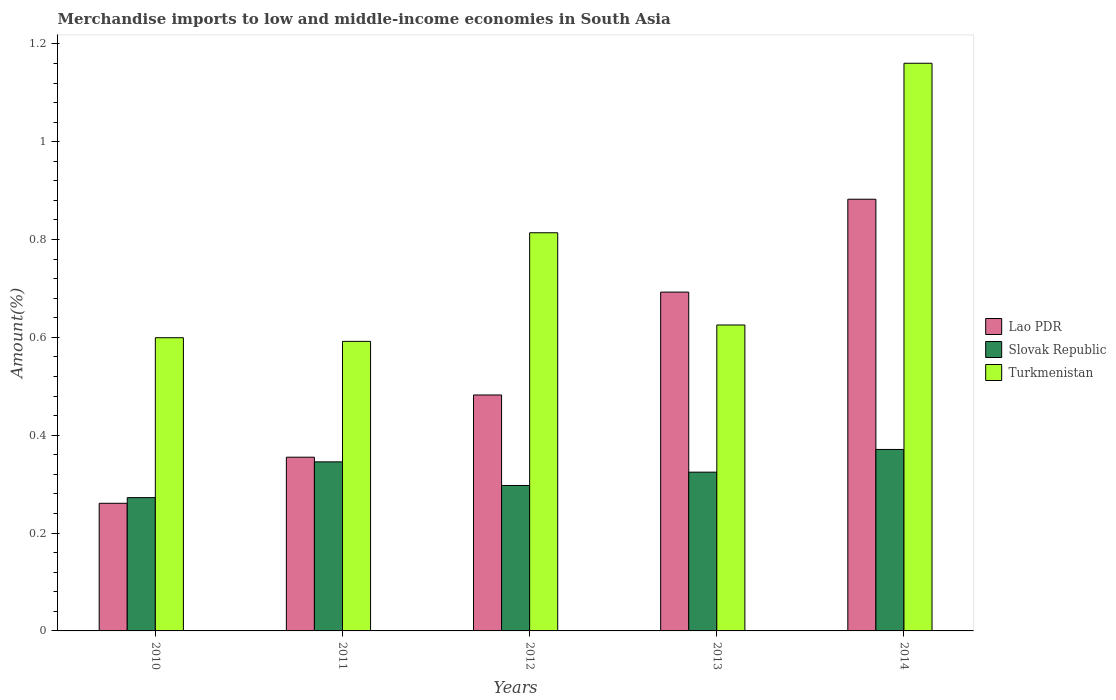How many groups of bars are there?
Your answer should be compact. 5. Are the number of bars per tick equal to the number of legend labels?
Your answer should be very brief. Yes. How many bars are there on the 4th tick from the left?
Keep it short and to the point. 3. How many bars are there on the 4th tick from the right?
Give a very brief answer. 3. What is the label of the 5th group of bars from the left?
Your answer should be compact. 2014. What is the percentage of amount earned from merchandise imports in Lao PDR in 2013?
Your answer should be compact. 0.69. Across all years, what is the maximum percentage of amount earned from merchandise imports in Turkmenistan?
Offer a terse response. 1.16. Across all years, what is the minimum percentage of amount earned from merchandise imports in Slovak Republic?
Offer a very short reply. 0.27. In which year was the percentage of amount earned from merchandise imports in Lao PDR maximum?
Offer a very short reply. 2014. What is the total percentage of amount earned from merchandise imports in Turkmenistan in the graph?
Offer a terse response. 3.79. What is the difference between the percentage of amount earned from merchandise imports in Turkmenistan in 2010 and that in 2014?
Provide a succinct answer. -0.56. What is the difference between the percentage of amount earned from merchandise imports in Lao PDR in 2011 and the percentage of amount earned from merchandise imports in Slovak Republic in 2010?
Your answer should be very brief. 0.08. What is the average percentage of amount earned from merchandise imports in Slovak Republic per year?
Give a very brief answer. 0.32. In the year 2013, what is the difference between the percentage of amount earned from merchandise imports in Turkmenistan and percentage of amount earned from merchandise imports in Slovak Republic?
Your answer should be very brief. 0.3. In how many years, is the percentage of amount earned from merchandise imports in Lao PDR greater than 0.68 %?
Provide a succinct answer. 2. What is the ratio of the percentage of amount earned from merchandise imports in Slovak Republic in 2011 to that in 2014?
Provide a short and direct response. 0.93. Is the difference between the percentage of amount earned from merchandise imports in Turkmenistan in 2010 and 2014 greater than the difference between the percentage of amount earned from merchandise imports in Slovak Republic in 2010 and 2014?
Offer a terse response. No. What is the difference between the highest and the second highest percentage of amount earned from merchandise imports in Turkmenistan?
Give a very brief answer. 0.35. What is the difference between the highest and the lowest percentage of amount earned from merchandise imports in Slovak Republic?
Keep it short and to the point. 0.1. What does the 1st bar from the left in 2012 represents?
Offer a very short reply. Lao PDR. What does the 2nd bar from the right in 2012 represents?
Give a very brief answer. Slovak Republic. What is the difference between two consecutive major ticks on the Y-axis?
Offer a terse response. 0.2. Does the graph contain any zero values?
Your answer should be very brief. No. Does the graph contain grids?
Your answer should be very brief. No. How many legend labels are there?
Your response must be concise. 3. What is the title of the graph?
Your response must be concise. Merchandise imports to low and middle-income economies in South Asia. What is the label or title of the X-axis?
Make the answer very short. Years. What is the label or title of the Y-axis?
Offer a very short reply. Amount(%). What is the Amount(%) of Lao PDR in 2010?
Give a very brief answer. 0.26. What is the Amount(%) of Slovak Republic in 2010?
Provide a succinct answer. 0.27. What is the Amount(%) in Turkmenistan in 2010?
Offer a very short reply. 0.6. What is the Amount(%) of Lao PDR in 2011?
Offer a terse response. 0.36. What is the Amount(%) in Slovak Republic in 2011?
Provide a succinct answer. 0.35. What is the Amount(%) in Turkmenistan in 2011?
Your response must be concise. 0.59. What is the Amount(%) of Lao PDR in 2012?
Keep it short and to the point. 0.48. What is the Amount(%) in Slovak Republic in 2012?
Your answer should be compact. 0.3. What is the Amount(%) of Turkmenistan in 2012?
Keep it short and to the point. 0.81. What is the Amount(%) in Lao PDR in 2013?
Provide a succinct answer. 0.69. What is the Amount(%) in Slovak Republic in 2013?
Your answer should be compact. 0.32. What is the Amount(%) in Turkmenistan in 2013?
Give a very brief answer. 0.63. What is the Amount(%) in Lao PDR in 2014?
Give a very brief answer. 0.88. What is the Amount(%) in Slovak Republic in 2014?
Ensure brevity in your answer.  0.37. What is the Amount(%) in Turkmenistan in 2014?
Your response must be concise. 1.16. Across all years, what is the maximum Amount(%) of Lao PDR?
Provide a succinct answer. 0.88. Across all years, what is the maximum Amount(%) of Slovak Republic?
Provide a short and direct response. 0.37. Across all years, what is the maximum Amount(%) of Turkmenistan?
Your answer should be very brief. 1.16. Across all years, what is the minimum Amount(%) in Lao PDR?
Make the answer very short. 0.26. Across all years, what is the minimum Amount(%) in Slovak Republic?
Provide a succinct answer. 0.27. Across all years, what is the minimum Amount(%) of Turkmenistan?
Provide a succinct answer. 0.59. What is the total Amount(%) in Lao PDR in the graph?
Keep it short and to the point. 2.67. What is the total Amount(%) of Slovak Republic in the graph?
Your answer should be compact. 1.61. What is the total Amount(%) in Turkmenistan in the graph?
Give a very brief answer. 3.79. What is the difference between the Amount(%) of Lao PDR in 2010 and that in 2011?
Ensure brevity in your answer.  -0.09. What is the difference between the Amount(%) of Slovak Republic in 2010 and that in 2011?
Your response must be concise. -0.07. What is the difference between the Amount(%) of Turkmenistan in 2010 and that in 2011?
Make the answer very short. 0.01. What is the difference between the Amount(%) of Lao PDR in 2010 and that in 2012?
Provide a succinct answer. -0.22. What is the difference between the Amount(%) of Slovak Republic in 2010 and that in 2012?
Keep it short and to the point. -0.02. What is the difference between the Amount(%) in Turkmenistan in 2010 and that in 2012?
Make the answer very short. -0.21. What is the difference between the Amount(%) of Lao PDR in 2010 and that in 2013?
Make the answer very short. -0.43. What is the difference between the Amount(%) of Slovak Republic in 2010 and that in 2013?
Make the answer very short. -0.05. What is the difference between the Amount(%) of Turkmenistan in 2010 and that in 2013?
Make the answer very short. -0.03. What is the difference between the Amount(%) of Lao PDR in 2010 and that in 2014?
Your answer should be very brief. -0.62. What is the difference between the Amount(%) of Slovak Republic in 2010 and that in 2014?
Ensure brevity in your answer.  -0.1. What is the difference between the Amount(%) of Turkmenistan in 2010 and that in 2014?
Ensure brevity in your answer.  -0.56. What is the difference between the Amount(%) in Lao PDR in 2011 and that in 2012?
Your answer should be very brief. -0.13. What is the difference between the Amount(%) of Slovak Republic in 2011 and that in 2012?
Provide a short and direct response. 0.05. What is the difference between the Amount(%) of Turkmenistan in 2011 and that in 2012?
Make the answer very short. -0.22. What is the difference between the Amount(%) in Lao PDR in 2011 and that in 2013?
Offer a terse response. -0.34. What is the difference between the Amount(%) in Slovak Republic in 2011 and that in 2013?
Ensure brevity in your answer.  0.02. What is the difference between the Amount(%) in Turkmenistan in 2011 and that in 2013?
Your response must be concise. -0.03. What is the difference between the Amount(%) of Lao PDR in 2011 and that in 2014?
Offer a very short reply. -0.53. What is the difference between the Amount(%) in Slovak Republic in 2011 and that in 2014?
Ensure brevity in your answer.  -0.03. What is the difference between the Amount(%) of Turkmenistan in 2011 and that in 2014?
Your response must be concise. -0.57. What is the difference between the Amount(%) of Lao PDR in 2012 and that in 2013?
Your answer should be very brief. -0.21. What is the difference between the Amount(%) in Slovak Republic in 2012 and that in 2013?
Ensure brevity in your answer.  -0.03. What is the difference between the Amount(%) of Turkmenistan in 2012 and that in 2013?
Offer a very short reply. 0.19. What is the difference between the Amount(%) of Lao PDR in 2012 and that in 2014?
Your answer should be compact. -0.4. What is the difference between the Amount(%) of Slovak Republic in 2012 and that in 2014?
Offer a terse response. -0.07. What is the difference between the Amount(%) in Turkmenistan in 2012 and that in 2014?
Give a very brief answer. -0.35. What is the difference between the Amount(%) in Lao PDR in 2013 and that in 2014?
Offer a terse response. -0.19. What is the difference between the Amount(%) of Slovak Republic in 2013 and that in 2014?
Ensure brevity in your answer.  -0.05. What is the difference between the Amount(%) of Turkmenistan in 2013 and that in 2014?
Give a very brief answer. -0.54. What is the difference between the Amount(%) in Lao PDR in 2010 and the Amount(%) in Slovak Republic in 2011?
Your answer should be compact. -0.08. What is the difference between the Amount(%) in Lao PDR in 2010 and the Amount(%) in Turkmenistan in 2011?
Offer a very short reply. -0.33. What is the difference between the Amount(%) of Slovak Republic in 2010 and the Amount(%) of Turkmenistan in 2011?
Your answer should be very brief. -0.32. What is the difference between the Amount(%) of Lao PDR in 2010 and the Amount(%) of Slovak Republic in 2012?
Give a very brief answer. -0.04. What is the difference between the Amount(%) in Lao PDR in 2010 and the Amount(%) in Turkmenistan in 2012?
Give a very brief answer. -0.55. What is the difference between the Amount(%) of Slovak Republic in 2010 and the Amount(%) of Turkmenistan in 2012?
Make the answer very short. -0.54. What is the difference between the Amount(%) in Lao PDR in 2010 and the Amount(%) in Slovak Republic in 2013?
Ensure brevity in your answer.  -0.06. What is the difference between the Amount(%) in Lao PDR in 2010 and the Amount(%) in Turkmenistan in 2013?
Your answer should be compact. -0.36. What is the difference between the Amount(%) of Slovak Republic in 2010 and the Amount(%) of Turkmenistan in 2013?
Offer a very short reply. -0.35. What is the difference between the Amount(%) in Lao PDR in 2010 and the Amount(%) in Slovak Republic in 2014?
Provide a succinct answer. -0.11. What is the difference between the Amount(%) of Lao PDR in 2010 and the Amount(%) of Turkmenistan in 2014?
Offer a terse response. -0.9. What is the difference between the Amount(%) of Slovak Republic in 2010 and the Amount(%) of Turkmenistan in 2014?
Keep it short and to the point. -0.89. What is the difference between the Amount(%) in Lao PDR in 2011 and the Amount(%) in Slovak Republic in 2012?
Offer a terse response. 0.06. What is the difference between the Amount(%) of Lao PDR in 2011 and the Amount(%) of Turkmenistan in 2012?
Give a very brief answer. -0.46. What is the difference between the Amount(%) in Slovak Republic in 2011 and the Amount(%) in Turkmenistan in 2012?
Make the answer very short. -0.47. What is the difference between the Amount(%) of Lao PDR in 2011 and the Amount(%) of Slovak Republic in 2013?
Keep it short and to the point. 0.03. What is the difference between the Amount(%) of Lao PDR in 2011 and the Amount(%) of Turkmenistan in 2013?
Give a very brief answer. -0.27. What is the difference between the Amount(%) in Slovak Republic in 2011 and the Amount(%) in Turkmenistan in 2013?
Offer a very short reply. -0.28. What is the difference between the Amount(%) of Lao PDR in 2011 and the Amount(%) of Slovak Republic in 2014?
Provide a succinct answer. -0.02. What is the difference between the Amount(%) in Lao PDR in 2011 and the Amount(%) in Turkmenistan in 2014?
Make the answer very short. -0.81. What is the difference between the Amount(%) in Slovak Republic in 2011 and the Amount(%) in Turkmenistan in 2014?
Offer a terse response. -0.81. What is the difference between the Amount(%) of Lao PDR in 2012 and the Amount(%) of Slovak Republic in 2013?
Offer a terse response. 0.16. What is the difference between the Amount(%) of Lao PDR in 2012 and the Amount(%) of Turkmenistan in 2013?
Keep it short and to the point. -0.14. What is the difference between the Amount(%) in Slovak Republic in 2012 and the Amount(%) in Turkmenistan in 2013?
Keep it short and to the point. -0.33. What is the difference between the Amount(%) of Lao PDR in 2012 and the Amount(%) of Slovak Republic in 2014?
Your answer should be compact. 0.11. What is the difference between the Amount(%) of Lao PDR in 2012 and the Amount(%) of Turkmenistan in 2014?
Your answer should be compact. -0.68. What is the difference between the Amount(%) of Slovak Republic in 2012 and the Amount(%) of Turkmenistan in 2014?
Your answer should be very brief. -0.86. What is the difference between the Amount(%) of Lao PDR in 2013 and the Amount(%) of Slovak Republic in 2014?
Provide a short and direct response. 0.32. What is the difference between the Amount(%) in Lao PDR in 2013 and the Amount(%) in Turkmenistan in 2014?
Offer a terse response. -0.47. What is the difference between the Amount(%) in Slovak Republic in 2013 and the Amount(%) in Turkmenistan in 2014?
Provide a succinct answer. -0.84. What is the average Amount(%) of Lao PDR per year?
Your answer should be compact. 0.53. What is the average Amount(%) in Slovak Republic per year?
Offer a very short reply. 0.32. What is the average Amount(%) in Turkmenistan per year?
Make the answer very short. 0.76. In the year 2010, what is the difference between the Amount(%) of Lao PDR and Amount(%) of Slovak Republic?
Offer a terse response. -0.01. In the year 2010, what is the difference between the Amount(%) of Lao PDR and Amount(%) of Turkmenistan?
Your response must be concise. -0.34. In the year 2010, what is the difference between the Amount(%) of Slovak Republic and Amount(%) of Turkmenistan?
Offer a terse response. -0.33. In the year 2011, what is the difference between the Amount(%) of Lao PDR and Amount(%) of Slovak Republic?
Provide a short and direct response. 0.01. In the year 2011, what is the difference between the Amount(%) of Lao PDR and Amount(%) of Turkmenistan?
Your response must be concise. -0.24. In the year 2011, what is the difference between the Amount(%) in Slovak Republic and Amount(%) in Turkmenistan?
Your answer should be compact. -0.25. In the year 2012, what is the difference between the Amount(%) in Lao PDR and Amount(%) in Slovak Republic?
Your answer should be compact. 0.18. In the year 2012, what is the difference between the Amount(%) in Lao PDR and Amount(%) in Turkmenistan?
Your answer should be very brief. -0.33. In the year 2012, what is the difference between the Amount(%) in Slovak Republic and Amount(%) in Turkmenistan?
Provide a succinct answer. -0.52. In the year 2013, what is the difference between the Amount(%) in Lao PDR and Amount(%) in Slovak Republic?
Keep it short and to the point. 0.37. In the year 2013, what is the difference between the Amount(%) in Lao PDR and Amount(%) in Turkmenistan?
Offer a terse response. 0.07. In the year 2013, what is the difference between the Amount(%) of Slovak Republic and Amount(%) of Turkmenistan?
Provide a succinct answer. -0.3. In the year 2014, what is the difference between the Amount(%) of Lao PDR and Amount(%) of Slovak Republic?
Your response must be concise. 0.51. In the year 2014, what is the difference between the Amount(%) of Lao PDR and Amount(%) of Turkmenistan?
Offer a very short reply. -0.28. In the year 2014, what is the difference between the Amount(%) in Slovak Republic and Amount(%) in Turkmenistan?
Provide a short and direct response. -0.79. What is the ratio of the Amount(%) in Lao PDR in 2010 to that in 2011?
Your response must be concise. 0.73. What is the ratio of the Amount(%) of Slovak Republic in 2010 to that in 2011?
Provide a succinct answer. 0.79. What is the ratio of the Amount(%) in Turkmenistan in 2010 to that in 2011?
Ensure brevity in your answer.  1.01. What is the ratio of the Amount(%) of Lao PDR in 2010 to that in 2012?
Ensure brevity in your answer.  0.54. What is the ratio of the Amount(%) in Slovak Republic in 2010 to that in 2012?
Provide a short and direct response. 0.92. What is the ratio of the Amount(%) in Turkmenistan in 2010 to that in 2012?
Ensure brevity in your answer.  0.74. What is the ratio of the Amount(%) of Lao PDR in 2010 to that in 2013?
Provide a short and direct response. 0.38. What is the ratio of the Amount(%) of Slovak Republic in 2010 to that in 2013?
Your response must be concise. 0.84. What is the ratio of the Amount(%) of Turkmenistan in 2010 to that in 2013?
Your answer should be compact. 0.96. What is the ratio of the Amount(%) of Lao PDR in 2010 to that in 2014?
Your answer should be compact. 0.3. What is the ratio of the Amount(%) of Slovak Republic in 2010 to that in 2014?
Make the answer very short. 0.73. What is the ratio of the Amount(%) of Turkmenistan in 2010 to that in 2014?
Keep it short and to the point. 0.52. What is the ratio of the Amount(%) in Lao PDR in 2011 to that in 2012?
Make the answer very short. 0.74. What is the ratio of the Amount(%) of Slovak Republic in 2011 to that in 2012?
Your answer should be compact. 1.16. What is the ratio of the Amount(%) of Turkmenistan in 2011 to that in 2012?
Your response must be concise. 0.73. What is the ratio of the Amount(%) of Lao PDR in 2011 to that in 2013?
Provide a succinct answer. 0.51. What is the ratio of the Amount(%) of Slovak Republic in 2011 to that in 2013?
Provide a short and direct response. 1.06. What is the ratio of the Amount(%) in Turkmenistan in 2011 to that in 2013?
Keep it short and to the point. 0.95. What is the ratio of the Amount(%) in Lao PDR in 2011 to that in 2014?
Keep it short and to the point. 0.4. What is the ratio of the Amount(%) of Slovak Republic in 2011 to that in 2014?
Give a very brief answer. 0.93. What is the ratio of the Amount(%) in Turkmenistan in 2011 to that in 2014?
Your answer should be compact. 0.51. What is the ratio of the Amount(%) in Lao PDR in 2012 to that in 2013?
Give a very brief answer. 0.7. What is the ratio of the Amount(%) in Slovak Republic in 2012 to that in 2013?
Your answer should be compact. 0.92. What is the ratio of the Amount(%) of Turkmenistan in 2012 to that in 2013?
Keep it short and to the point. 1.3. What is the ratio of the Amount(%) in Lao PDR in 2012 to that in 2014?
Provide a short and direct response. 0.55. What is the ratio of the Amount(%) of Slovak Republic in 2012 to that in 2014?
Provide a short and direct response. 0.8. What is the ratio of the Amount(%) of Turkmenistan in 2012 to that in 2014?
Offer a very short reply. 0.7. What is the ratio of the Amount(%) of Lao PDR in 2013 to that in 2014?
Ensure brevity in your answer.  0.78. What is the ratio of the Amount(%) in Slovak Republic in 2013 to that in 2014?
Offer a very short reply. 0.87. What is the ratio of the Amount(%) in Turkmenistan in 2013 to that in 2014?
Make the answer very short. 0.54. What is the difference between the highest and the second highest Amount(%) in Lao PDR?
Ensure brevity in your answer.  0.19. What is the difference between the highest and the second highest Amount(%) of Slovak Republic?
Your answer should be compact. 0.03. What is the difference between the highest and the second highest Amount(%) of Turkmenistan?
Keep it short and to the point. 0.35. What is the difference between the highest and the lowest Amount(%) in Lao PDR?
Offer a very short reply. 0.62. What is the difference between the highest and the lowest Amount(%) of Slovak Republic?
Give a very brief answer. 0.1. What is the difference between the highest and the lowest Amount(%) of Turkmenistan?
Keep it short and to the point. 0.57. 